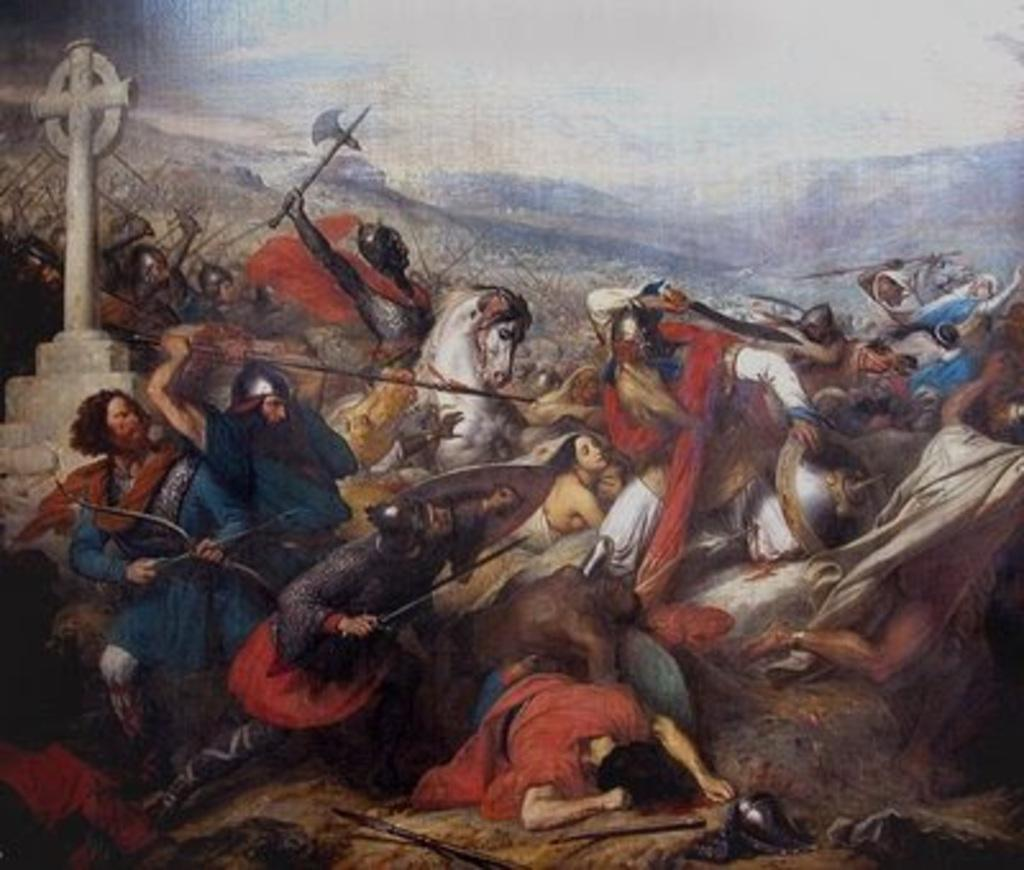What is the main subject of the image? The main subject of the image is a photo of people. What are some of the people holding in the image? Some people are holding axes and shields, while others are holding rods. What objects can be seen behind the people? There is a horse and a pole visible behind the people. What can be seen in the background of the image? Hills are visible in the background of the image. How many prisoners can be seen in the image? There are no prisoners present in the image; it features people holding various objects and a horse in the background. What type of comb is being used by the people in the image? There is no comb visible in the image; the people are holding axes, shields, and rods. 